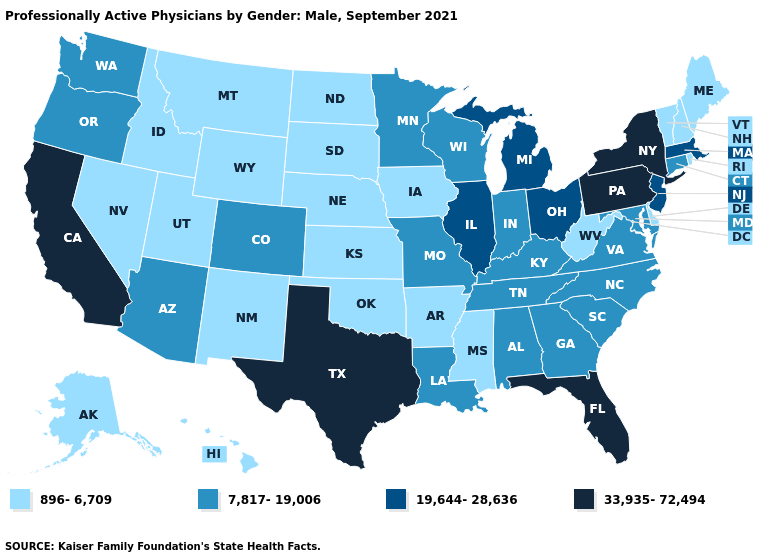Does the map have missing data?
Short answer required. No. Does Vermont have the same value as Connecticut?
Keep it brief. No. Among the states that border New Jersey , does Pennsylvania have the highest value?
Short answer required. Yes. What is the lowest value in the West?
Short answer required. 896-6,709. Does the first symbol in the legend represent the smallest category?
Write a very short answer. Yes. What is the value of Alaska?
Quick response, please. 896-6,709. Does Iowa have the lowest value in the MidWest?
Keep it brief. Yes. Among the states that border Nevada , which have the highest value?
Keep it brief. California. Name the states that have a value in the range 896-6,709?
Keep it brief. Alaska, Arkansas, Delaware, Hawaii, Idaho, Iowa, Kansas, Maine, Mississippi, Montana, Nebraska, Nevada, New Hampshire, New Mexico, North Dakota, Oklahoma, Rhode Island, South Dakota, Utah, Vermont, West Virginia, Wyoming. Does the map have missing data?
Keep it brief. No. Does Texas have a lower value than Colorado?
Quick response, please. No. Among the states that border Rhode Island , which have the lowest value?
Quick response, please. Connecticut. What is the highest value in the USA?
Write a very short answer. 33,935-72,494. Does Louisiana have the lowest value in the USA?
Be succinct. No. Does Illinois have a lower value than New York?
Write a very short answer. Yes. 